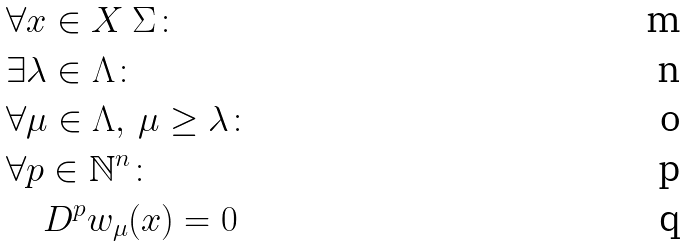<formula> <loc_0><loc_0><loc_500><loc_500>& \forall x \in X \ \Sigma \colon \\ & \exists \lambda \in \Lambda \colon \\ & \forall \mu \in \Lambda , \, \mu \geq \lambda \colon \\ & \forall p \in \mathbb { N } ^ { n } \colon \\ & \quad D ^ { p } w _ { \mu } ( x ) = 0</formula> 